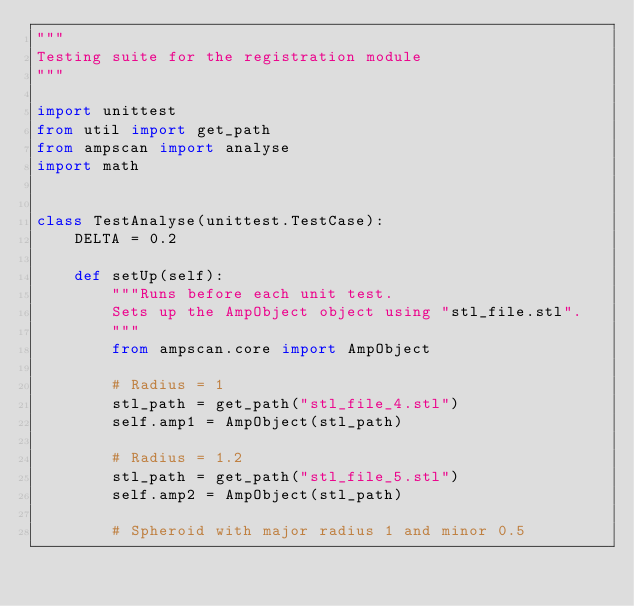Convert code to text. <code><loc_0><loc_0><loc_500><loc_500><_Python_>"""
Testing suite for the registration module
"""

import unittest
from util import get_path
from ampscan import analyse
import math


class TestAnalyse(unittest.TestCase):
    DELTA = 0.2

    def setUp(self):
        """Runs before each unit test.
        Sets up the AmpObject object using "stl_file.stl".
        """
        from ampscan.core import AmpObject

        # Radius = 1
        stl_path = get_path("stl_file_4.stl")
        self.amp1 = AmpObject(stl_path)

        # Radius = 1.2
        stl_path = get_path("stl_file_5.stl")
        self.amp2 = AmpObject(stl_path)

        # Spheroid with major radius 1 and minor 0.5</code> 